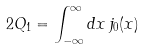<formula> <loc_0><loc_0><loc_500><loc_500>2 Q _ { 1 } = \int _ { - \infty } ^ { \infty } d x \, j _ { 0 } ( x )</formula> 